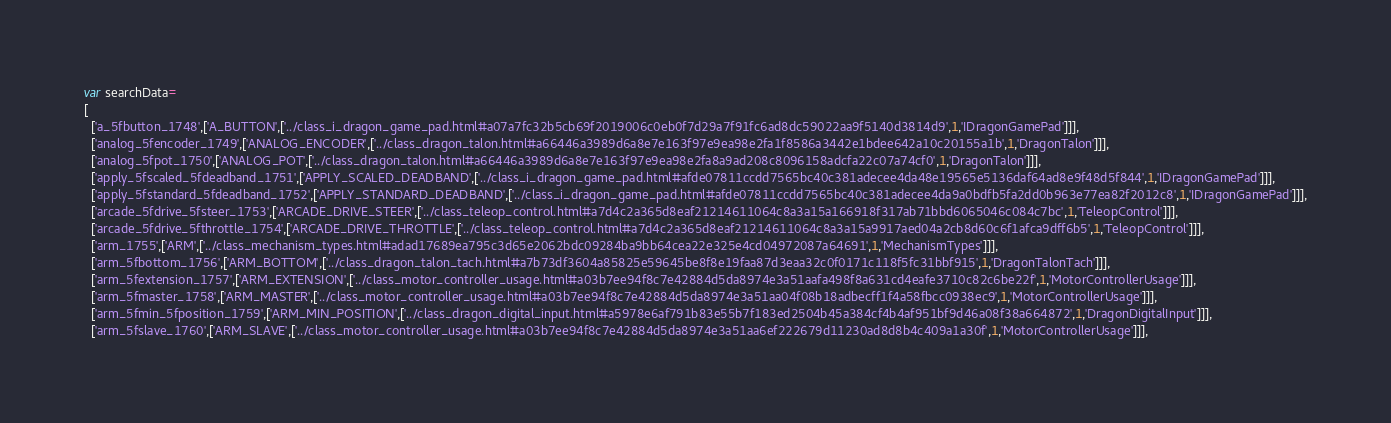Convert code to text. <code><loc_0><loc_0><loc_500><loc_500><_JavaScript_>var searchData=
[
  ['a_5fbutton_1748',['A_BUTTON',['../class_i_dragon_game_pad.html#a07a7fc32b5cb69f2019006c0eb0f7d29a7f91fc6ad8dc59022aa9f5140d3814d9',1,'IDragonGamePad']]],
  ['analog_5fencoder_1749',['ANALOG_ENCODER',['../class_dragon_talon.html#a66446a3989d6a8e7e163f97e9ea98e2fa1f8586a3442e1bdee642a10c20155a1b',1,'DragonTalon']]],
  ['analog_5fpot_1750',['ANALOG_POT',['../class_dragon_talon.html#a66446a3989d6a8e7e163f97e9ea98e2fa8a9ad208c8096158adcfa22c07a74cf0',1,'DragonTalon']]],
  ['apply_5fscaled_5fdeadband_1751',['APPLY_SCALED_DEADBAND',['../class_i_dragon_game_pad.html#afde07811ccdd7565bc40c381adecee4da48e19565e5136daf64ad8e9f48d5f844',1,'IDragonGamePad']]],
  ['apply_5fstandard_5fdeadband_1752',['APPLY_STANDARD_DEADBAND',['../class_i_dragon_game_pad.html#afde07811ccdd7565bc40c381adecee4da9a0bdfb5fa2dd0b963e77ea82f2012c8',1,'IDragonGamePad']]],
  ['arcade_5fdrive_5fsteer_1753',['ARCADE_DRIVE_STEER',['../class_teleop_control.html#a7d4c2a365d8eaf21214611064c8a3a15a166918f317ab71bbd6065046c084c7bc',1,'TeleopControl']]],
  ['arcade_5fdrive_5fthrottle_1754',['ARCADE_DRIVE_THROTTLE',['../class_teleop_control.html#a7d4c2a365d8eaf21214611064c8a3a15a9917aed04a2cb8d60c6f1afca9dff6b5',1,'TeleopControl']]],
  ['arm_1755',['ARM',['../class_mechanism_types.html#adad17689ea795c3d65e2062bdc09284ba9bb64cea22e325e4cd04972087a64691',1,'MechanismTypes']]],
  ['arm_5fbottom_1756',['ARM_BOTTOM',['../class_dragon_talon_tach.html#a7b73df3604a85825e59645be8f8e19faa87d3eaa32c0f0171c118f5fc31bbf915',1,'DragonTalonTach']]],
  ['arm_5fextension_1757',['ARM_EXTENSION',['../class_motor_controller_usage.html#a03b7ee94f8c7e42884d5da8974e3a51aafa498f8a631cd4eafe3710c82c6be22f',1,'MotorControllerUsage']]],
  ['arm_5fmaster_1758',['ARM_MASTER',['../class_motor_controller_usage.html#a03b7ee94f8c7e42884d5da8974e3a51aa04f08b18adbecff1f4a58fbcc0938ec9',1,'MotorControllerUsage']]],
  ['arm_5fmin_5fposition_1759',['ARM_MIN_POSITION',['../class_dragon_digital_input.html#a5978e6af791b83e55b7f183ed2504b45a384cf4b4af951bf9d46a08f38a664872',1,'DragonDigitalInput']]],
  ['arm_5fslave_1760',['ARM_SLAVE',['../class_motor_controller_usage.html#a03b7ee94f8c7e42884d5da8974e3a51aa6ef222679d11230ad8d8b4c409a1a30f',1,'MotorControllerUsage']]],</code> 